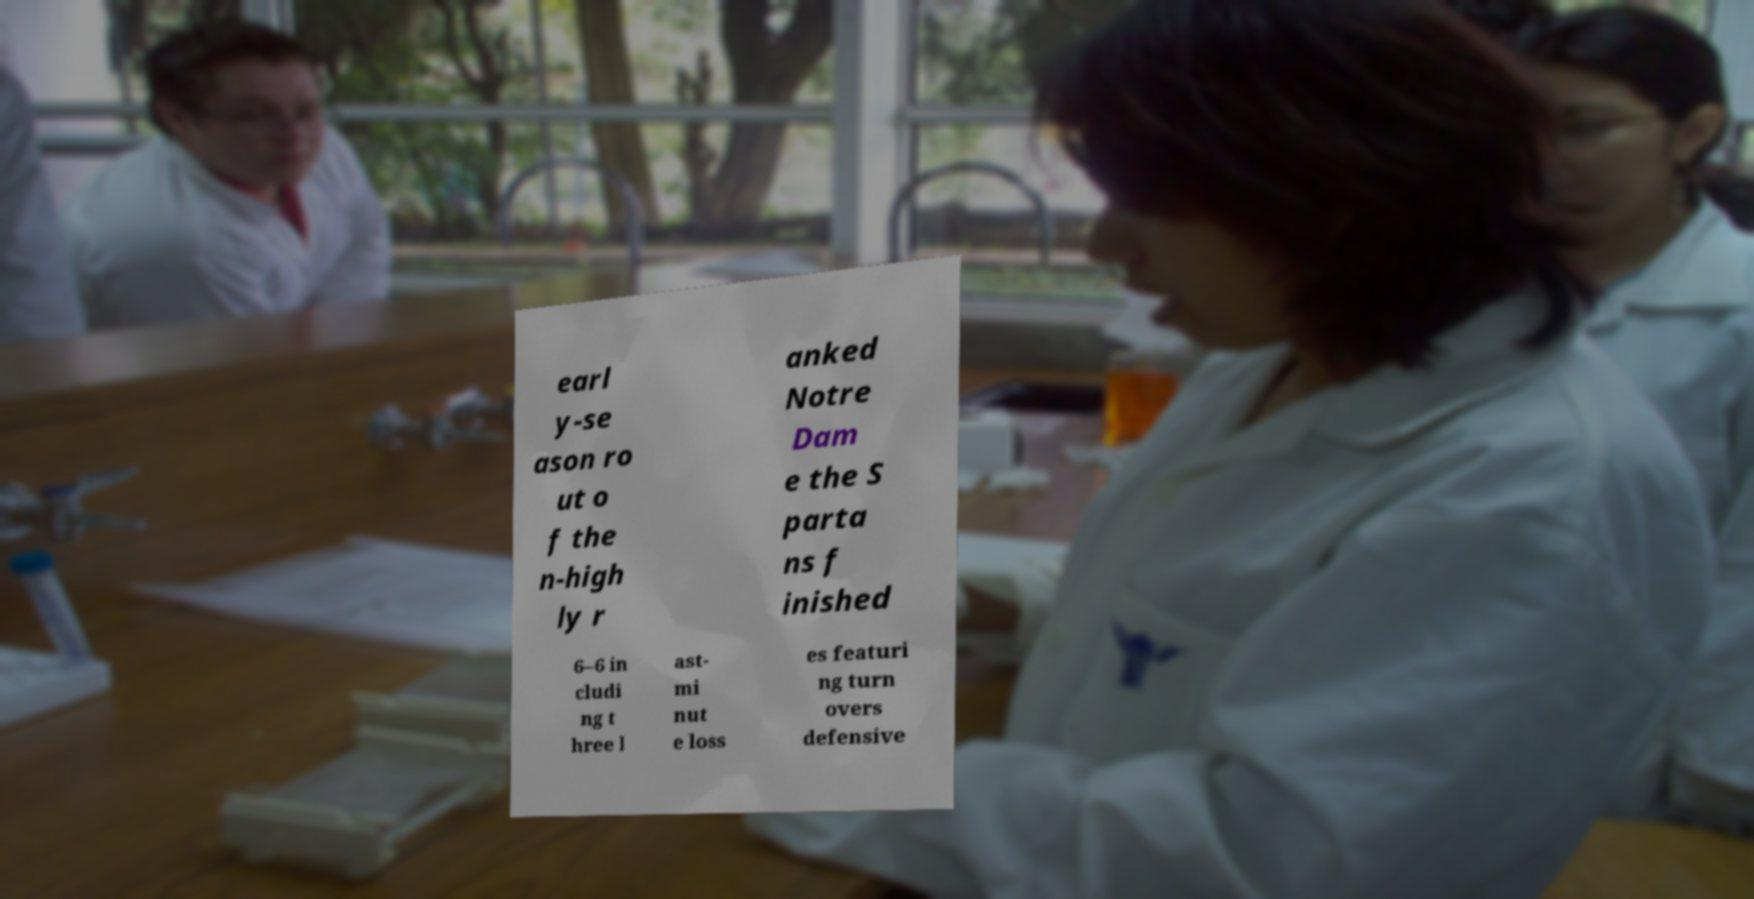Can you read and provide the text displayed in the image?This photo seems to have some interesting text. Can you extract and type it out for me? earl y-se ason ro ut o f the n-high ly r anked Notre Dam e the S parta ns f inished 6–6 in cludi ng t hree l ast- mi nut e loss es featuri ng turn overs defensive 